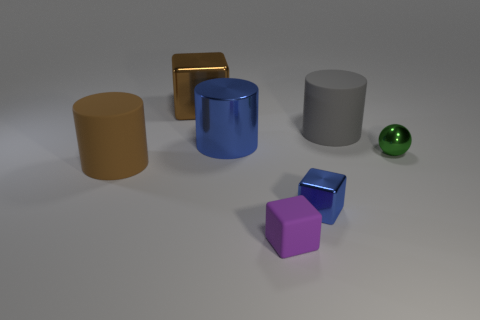Add 3 blue rubber blocks. How many objects exist? 10 Subtract all spheres. How many objects are left? 6 Add 4 big brown metal objects. How many big brown metal objects exist? 5 Subtract 1 blue cylinders. How many objects are left? 6 Subtract all small cyan balls. Subtract all blue metal blocks. How many objects are left? 6 Add 4 tiny rubber cubes. How many tiny rubber cubes are left? 5 